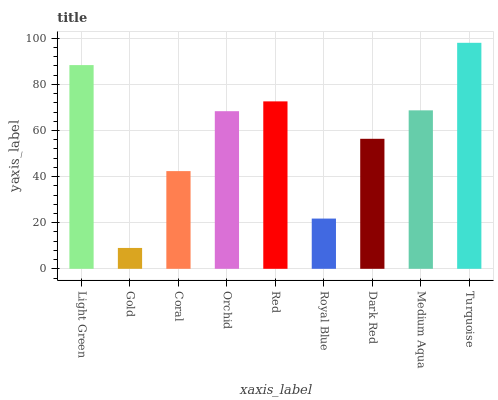Is Gold the minimum?
Answer yes or no. Yes. Is Turquoise the maximum?
Answer yes or no. Yes. Is Coral the minimum?
Answer yes or no. No. Is Coral the maximum?
Answer yes or no. No. Is Coral greater than Gold?
Answer yes or no. Yes. Is Gold less than Coral?
Answer yes or no. Yes. Is Gold greater than Coral?
Answer yes or no. No. Is Coral less than Gold?
Answer yes or no. No. Is Orchid the high median?
Answer yes or no. Yes. Is Orchid the low median?
Answer yes or no. Yes. Is Turquoise the high median?
Answer yes or no. No. Is Medium Aqua the low median?
Answer yes or no. No. 